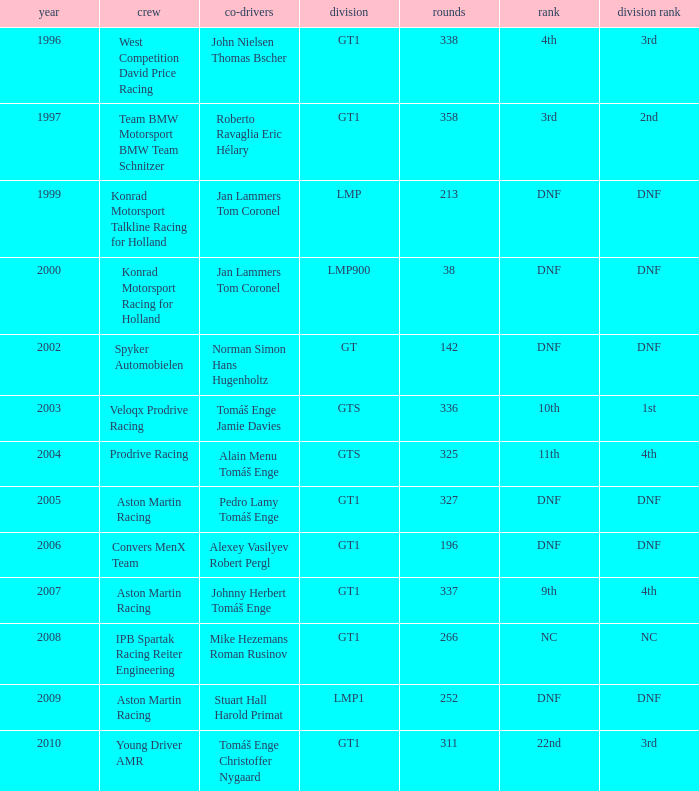Which team finished 3rd in class with 337 laps before 2008? West Competition David Price Racing. 